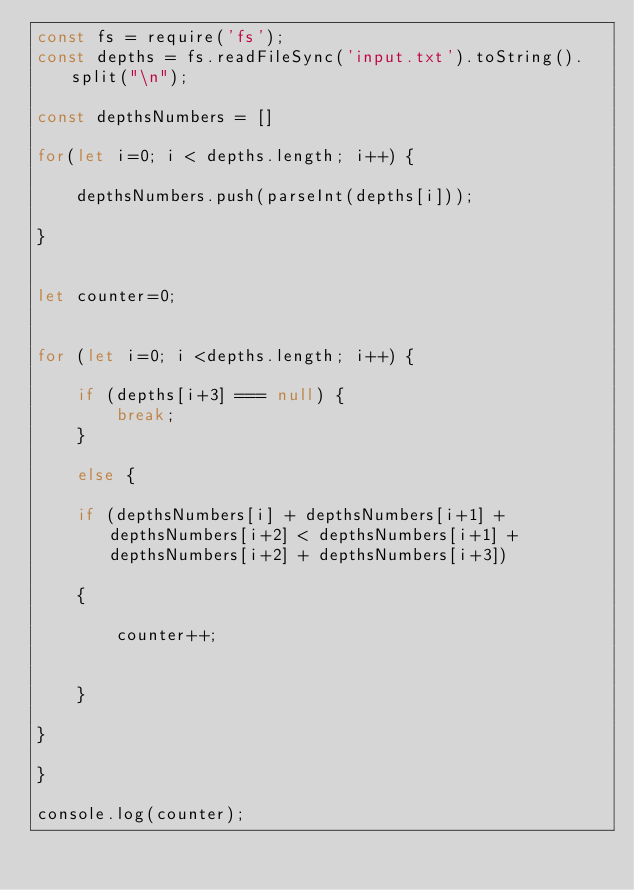Convert code to text. <code><loc_0><loc_0><loc_500><loc_500><_JavaScript_>const fs = require('fs');
const depths = fs.readFileSync('input.txt').toString().split("\n");

const depthsNumbers = []

for(let i=0; i < depths.length; i++) {

    depthsNumbers.push(parseInt(depths[i]));

}


let counter=0;


for (let i=0; i <depths.length; i++) {

    if (depths[i+3] === null) { 
        break;
    }

    else {
   
    if (depthsNumbers[i] + depthsNumbers[i+1] + depthsNumbers[i+2] < depthsNumbers[i+1] + depthsNumbers[i+2] + depthsNumbers[i+3]) 

    {
        
        counter++;

        
    }

}

}

console.log(counter);



</code> 